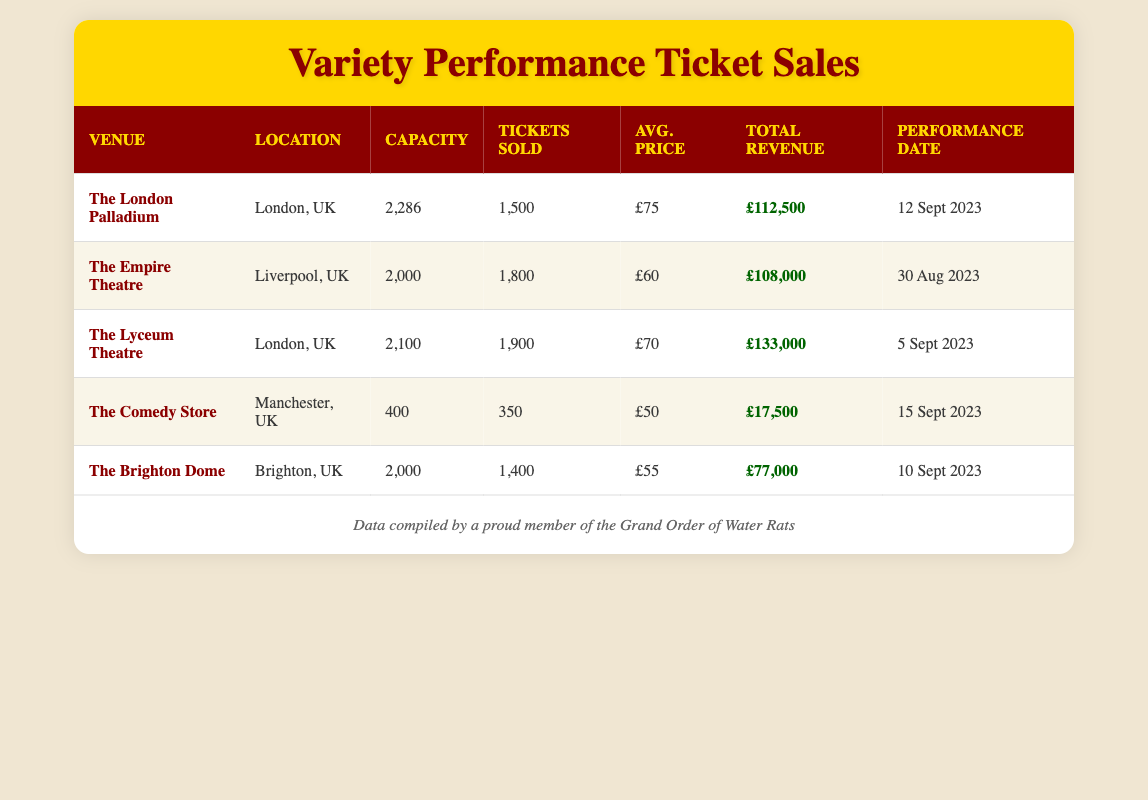What is the total revenue for The Empire Theatre? The total revenue is directly stated in the table under the "Total Revenue" column for The Empire Theatre, which shows £108,000.
Answer: £108,000 How many tickets were sold at The Comedy Store? The number of tickets sold is listed under the "Tickets Sold" column for The Comedy Store, which indicates 350 tickets were sold.
Answer: 350 Which venue had the highest average ticket price? To determine the highest average ticket price, we compare the "Avg. Price" for each venue. The London Palladium has the highest average ticket price of £75.
Answer: £75 What is the total capacity of all venues combined? We sum the capacities from all venues: 2286 (The London Palladium) + 2000 (The Empire Theatre) + 2100 (The Lyceum Theatre) + 400 (The Comedy Store) + 2000 (The Brighton Dome) = 10,786.
Answer: 10,786 Did The Brighton Dome sell more tickets than The Comedy Store? A comparison of the "Tickets Sold" shows The Brighton Dome sold 1400 tickets while The Comedy Store sold 350 tickets. Thus, The Brighton Dome sold more tickets.
Answer: Yes What is the average revenue generated per ticket at The Lyceum Theatre? The total revenue for The Lyceum Theatre is £133,000, and the number of tickets sold is 1900. To find the average revenue per ticket, we divide £133,000 by 1900, which equals approximately £70.
Answer: £70 Which venue has the lowest revenue? By inspecting the "Total Revenue" column, we see that The Comedy Store has the lowest revenue of £17,500 compared to other venues.
Answer: £17,500 What is the difference in ticket sales between The Lyceum Theatre and The Brighton Dome? To find the difference, we subtract the tickets sold at The Brighton Dome (1400) from The Lyceum Theatre (1900): 1900 - 1400 = 500.
Answer: 500 Which venue located in London sold the most tickets? Among the venues in London, The Lyceum Theatre with 1900 tickets sold is the highest when compared to The London Palladium's 1500 tickets.
Answer: The Lyceum Theatre 